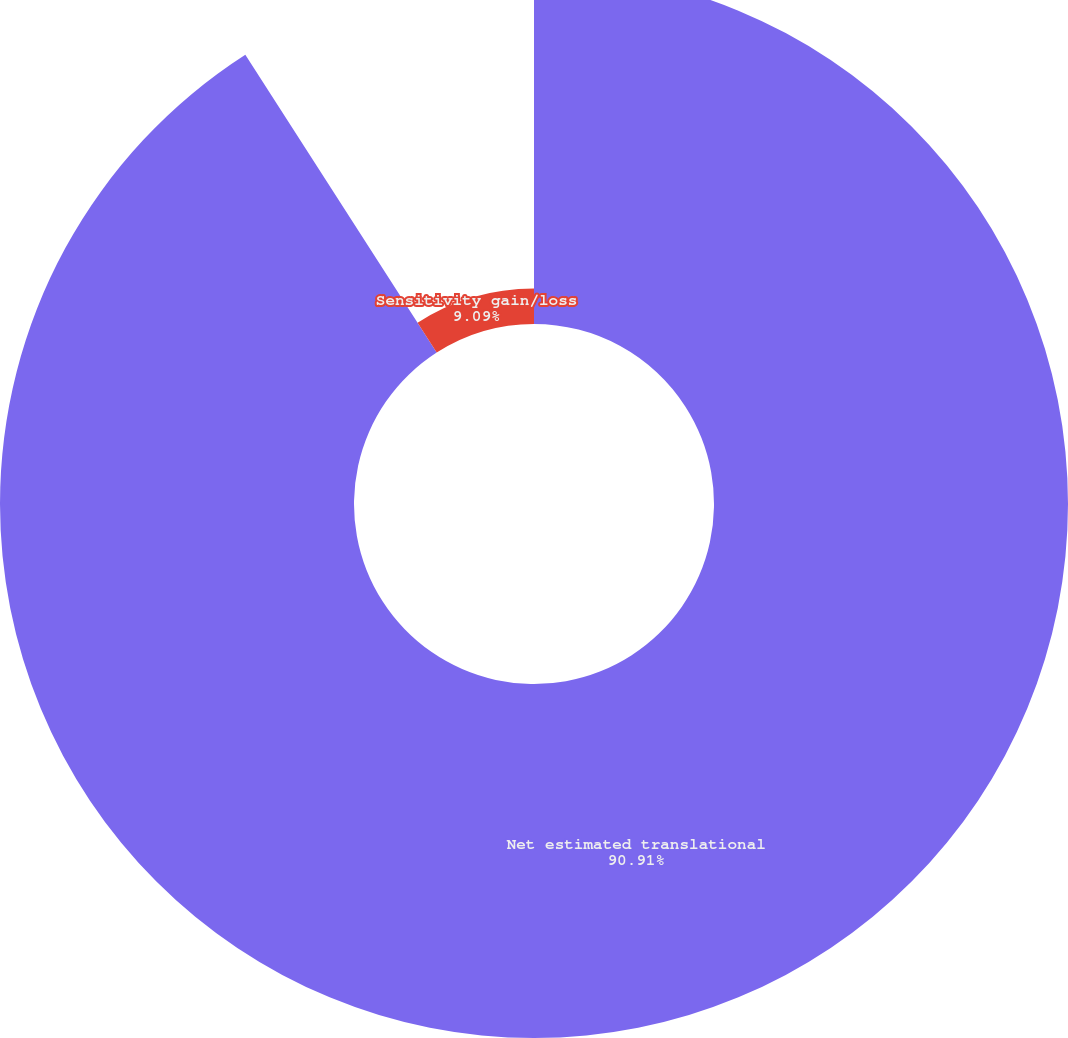Convert chart to OTSL. <chart><loc_0><loc_0><loc_500><loc_500><pie_chart><fcel>Net estimated translational<fcel>Sensitivity gain/loss<nl><fcel>90.91%<fcel>9.09%<nl></chart> 